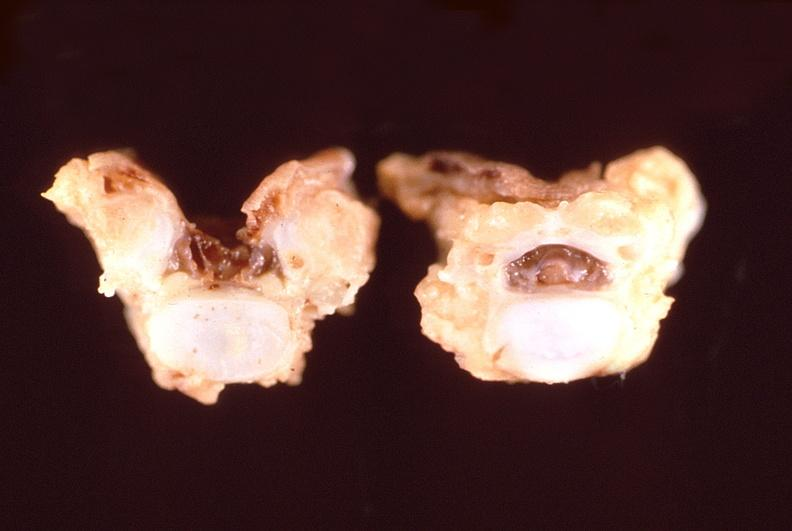does this image show neural tube defect, vertebral bodies?
Answer the question using a single word or phrase. Yes 